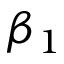Convert formula to latex. <formula><loc_0><loc_0><loc_500><loc_500>\beta _ { 1 }</formula> 